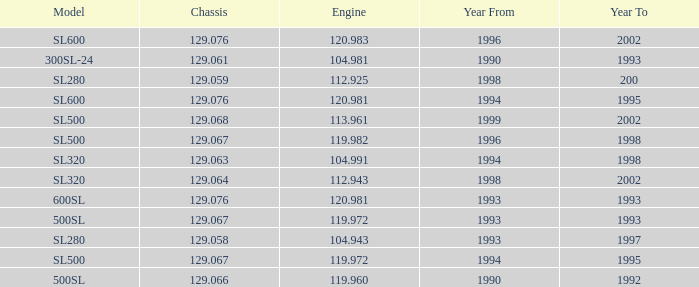Which Engine has a Model of sl500, and a Chassis smaller than 129.067? None. 